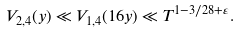<formula> <loc_0><loc_0><loc_500><loc_500>V _ { 2 , 4 } ( y ) \ll V _ { 1 , 4 } ( 1 6 y ) \ll T ^ { 1 - 3 / 2 8 + \varepsilon } .</formula> 